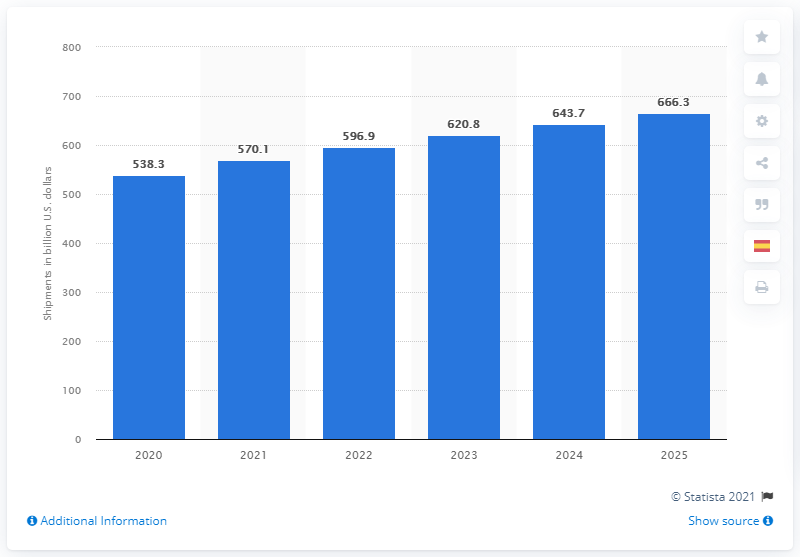Point out several critical features in this image. According to projections, the value of shipments in the chemical industry is expected to reach approximately 666.3 billion U.S. dollars in the year 2025. According to estimates, the value of shipments in the chemical industry was approximately $538.3 million in 2025. The estimated value of shipments in the chemical industry of the United States in 2025 is approximately 666.3. 